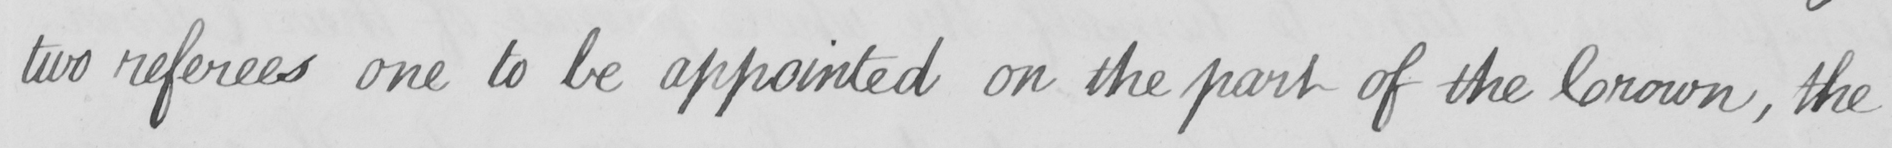What is written in this line of handwriting? two referees one to be appointed on the part of the Crown , the 